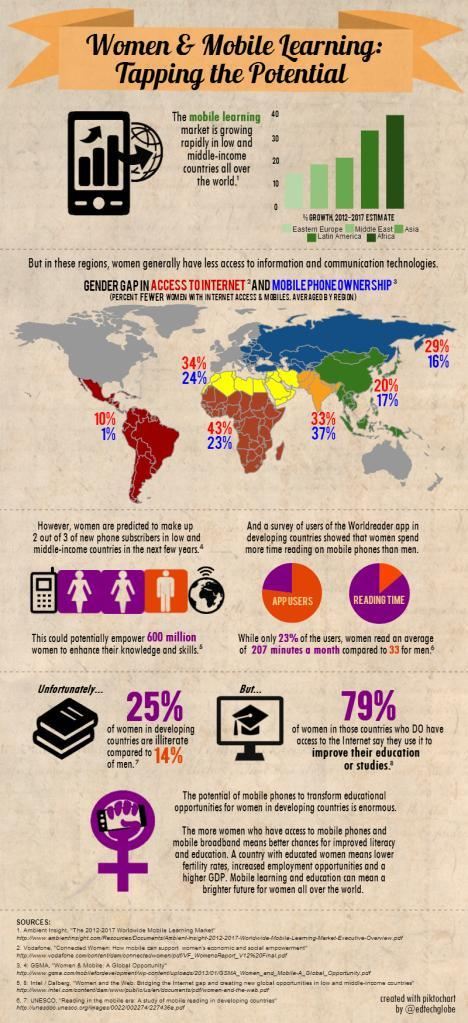Which region has shown the highest growth in mobile learning between 2012 and 2017?
Answer the question with a short phrase. Africa Which region has the highest gender gap in internet access - India, Middle East or Africa? Africa What % of women in developing countries are illiterate? 25% Out of every 3 new phone subscribers in low and middle-income countries, how many are men? 1 What percent of men in developing countries are illiterate? 14% Which regions have less than 20% growth in mobile learning market? Eastern Europe, Middle East Which region has a higher gender gap in mobile ownership - India or the Middle East? India What percentage of 'reading app users' are women? 23% What percentage of women in countries that have internet facilities use their mobile to improve their education? 79% 